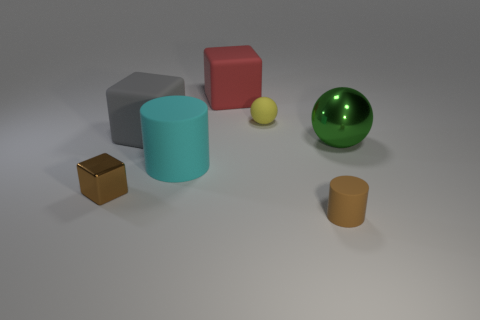Add 1 tiny yellow blocks. How many objects exist? 8 Subtract all cylinders. How many objects are left? 5 Add 3 brown metallic cubes. How many brown metallic cubes exist? 4 Subtract 0 yellow cylinders. How many objects are left? 7 Subtract all large brown rubber balls. Subtract all matte objects. How many objects are left? 2 Add 2 small cylinders. How many small cylinders are left? 3 